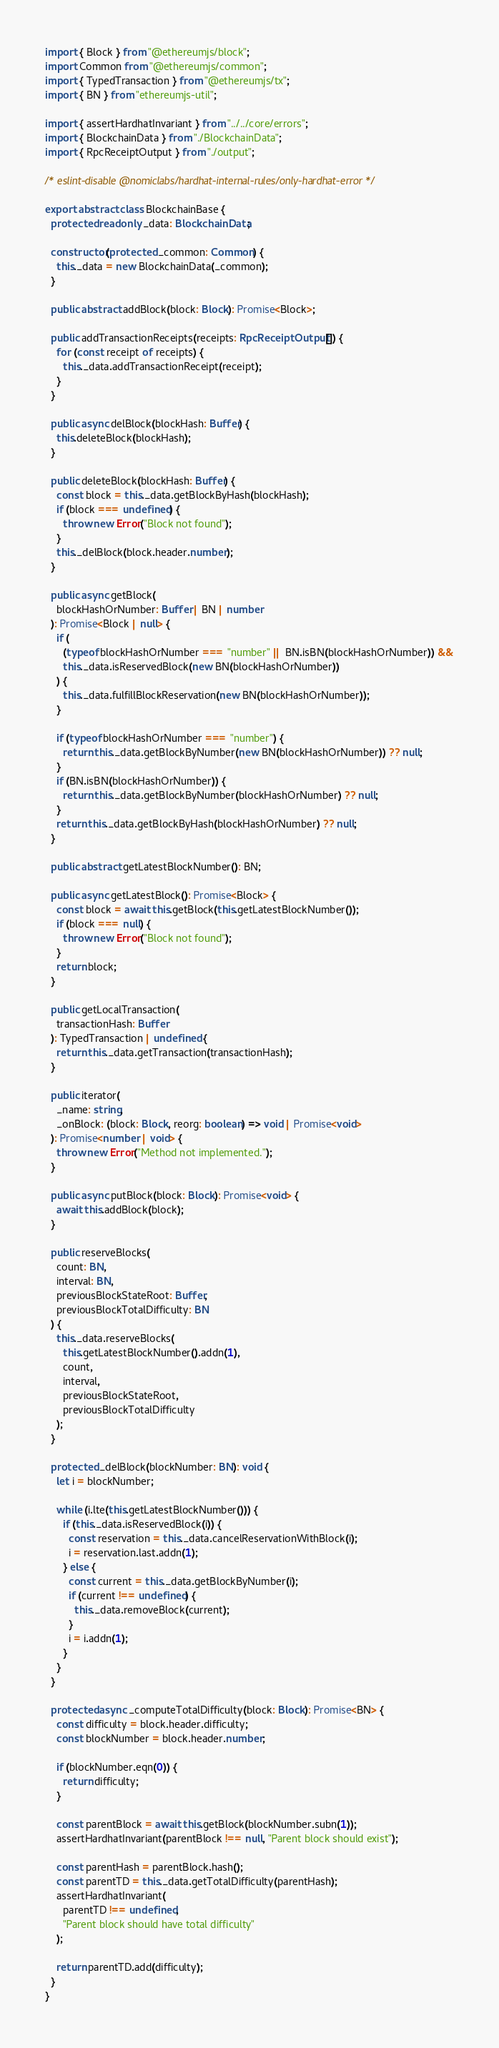<code> <loc_0><loc_0><loc_500><loc_500><_TypeScript_>import { Block } from "@ethereumjs/block";
import Common from "@ethereumjs/common";
import { TypedTransaction } from "@ethereumjs/tx";
import { BN } from "ethereumjs-util";

import { assertHardhatInvariant } from "../../core/errors";
import { BlockchainData } from "./BlockchainData";
import { RpcReceiptOutput } from "./output";

/* eslint-disable @nomiclabs/hardhat-internal-rules/only-hardhat-error */

export abstract class BlockchainBase {
  protected readonly _data: BlockchainData;

  constructor(protected _common: Common) {
    this._data = new BlockchainData(_common);
  }

  public abstract addBlock(block: Block): Promise<Block>;

  public addTransactionReceipts(receipts: RpcReceiptOutput[]) {
    for (const receipt of receipts) {
      this._data.addTransactionReceipt(receipt);
    }
  }

  public async delBlock(blockHash: Buffer) {
    this.deleteBlock(blockHash);
  }

  public deleteBlock(blockHash: Buffer) {
    const block = this._data.getBlockByHash(blockHash);
    if (block === undefined) {
      throw new Error("Block not found");
    }
    this._delBlock(block.header.number);
  }

  public async getBlock(
    blockHashOrNumber: Buffer | BN | number
  ): Promise<Block | null> {
    if (
      (typeof blockHashOrNumber === "number" || BN.isBN(blockHashOrNumber)) &&
      this._data.isReservedBlock(new BN(blockHashOrNumber))
    ) {
      this._data.fulfillBlockReservation(new BN(blockHashOrNumber));
    }

    if (typeof blockHashOrNumber === "number") {
      return this._data.getBlockByNumber(new BN(blockHashOrNumber)) ?? null;
    }
    if (BN.isBN(blockHashOrNumber)) {
      return this._data.getBlockByNumber(blockHashOrNumber) ?? null;
    }
    return this._data.getBlockByHash(blockHashOrNumber) ?? null;
  }

  public abstract getLatestBlockNumber(): BN;

  public async getLatestBlock(): Promise<Block> {
    const block = await this.getBlock(this.getLatestBlockNumber());
    if (block === null) {
      throw new Error("Block not found");
    }
    return block;
  }

  public getLocalTransaction(
    transactionHash: Buffer
  ): TypedTransaction | undefined {
    return this._data.getTransaction(transactionHash);
  }

  public iterator(
    _name: string,
    _onBlock: (block: Block, reorg: boolean) => void | Promise<void>
  ): Promise<number | void> {
    throw new Error("Method not implemented.");
  }

  public async putBlock(block: Block): Promise<void> {
    await this.addBlock(block);
  }

  public reserveBlocks(
    count: BN,
    interval: BN,
    previousBlockStateRoot: Buffer,
    previousBlockTotalDifficulty: BN
  ) {
    this._data.reserveBlocks(
      this.getLatestBlockNumber().addn(1),
      count,
      interval,
      previousBlockStateRoot,
      previousBlockTotalDifficulty
    );
  }

  protected _delBlock(blockNumber: BN): void {
    let i = blockNumber;

    while (i.lte(this.getLatestBlockNumber())) {
      if (this._data.isReservedBlock(i)) {
        const reservation = this._data.cancelReservationWithBlock(i);
        i = reservation.last.addn(1);
      } else {
        const current = this._data.getBlockByNumber(i);
        if (current !== undefined) {
          this._data.removeBlock(current);
        }
        i = i.addn(1);
      }
    }
  }

  protected async _computeTotalDifficulty(block: Block): Promise<BN> {
    const difficulty = block.header.difficulty;
    const blockNumber = block.header.number;

    if (blockNumber.eqn(0)) {
      return difficulty;
    }

    const parentBlock = await this.getBlock(blockNumber.subn(1));
    assertHardhatInvariant(parentBlock !== null, "Parent block should exist");

    const parentHash = parentBlock.hash();
    const parentTD = this._data.getTotalDifficulty(parentHash);
    assertHardhatInvariant(
      parentTD !== undefined,
      "Parent block should have total difficulty"
    );

    return parentTD.add(difficulty);
  }
}
</code> 